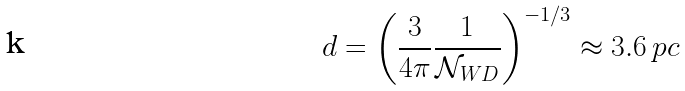Convert formula to latex. <formula><loc_0><loc_0><loc_500><loc_500>d = \left ( \frac { 3 } { 4 \pi } \frac { 1 } { \mathcal { N } _ { W D } } \right ) ^ { - 1 / 3 } \approx 3 . 6 \, p c</formula> 